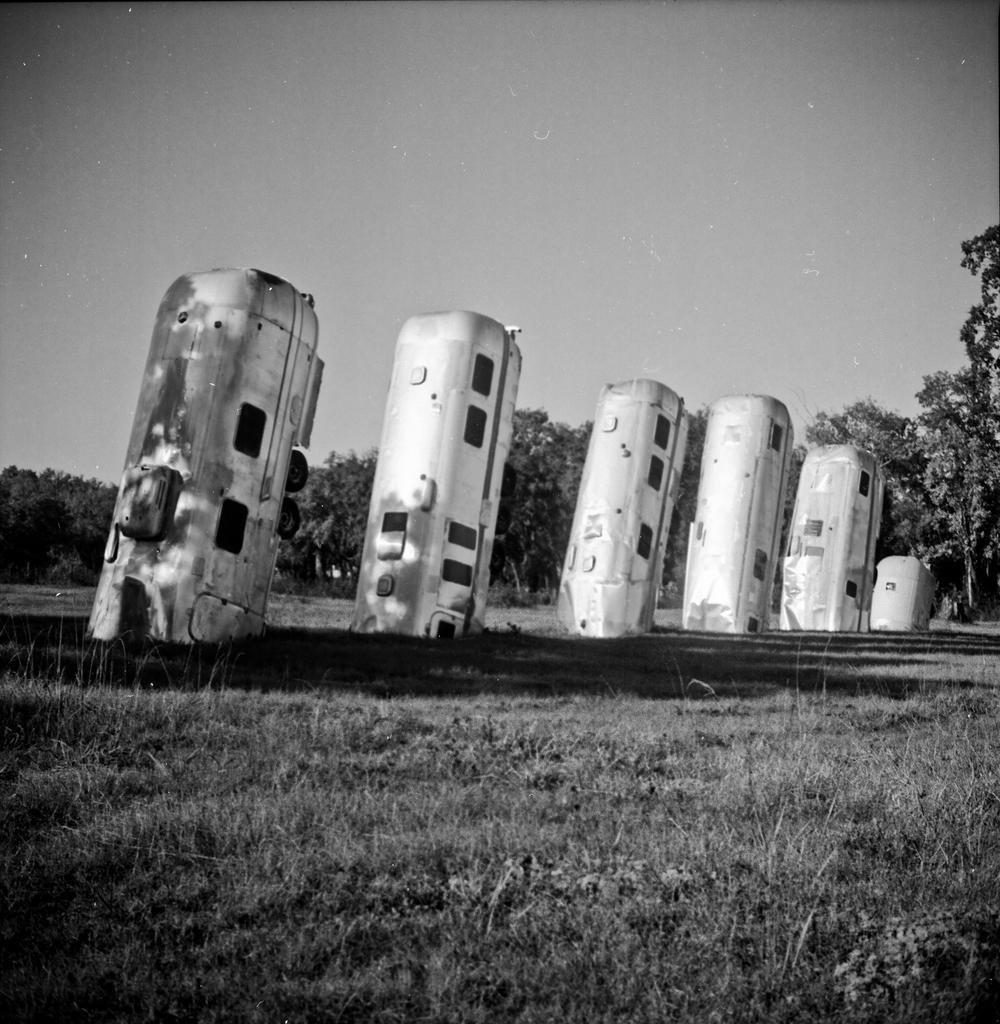Please provide a concise description of this image. In this image we can see some vehicles which are half in the ground and at the background of the image there are some trees and clear sky. 